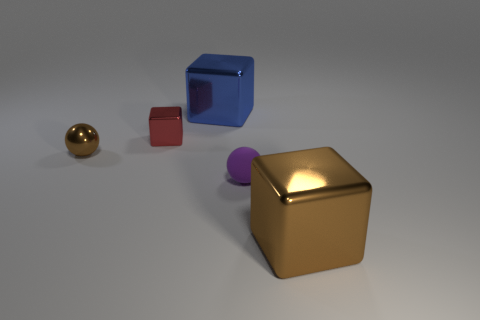There is a object that is the same size as the brown cube; what is its shape?
Keep it short and to the point. Cube. What is the color of the small thing that is on the left side of the small purple rubber sphere and on the right side of the small brown object?
Offer a terse response. Red. Is the size of the red metal thing the same as the shiny ball?
Offer a very short reply. Yes. What is the shape of the brown shiny thing left of the big metal block that is left of the big cube to the right of the big blue shiny block?
Keep it short and to the point. Sphere. Are there more tiny red things than small blue things?
Your answer should be compact. Yes. Are any brown cubes visible?
Provide a succinct answer. Yes. What number of things are either small things behind the tiny rubber thing or big objects that are to the right of the big blue shiny object?
Offer a very short reply. 3. Are there fewer matte objects than brown objects?
Offer a very short reply. Yes. Are there any tiny brown metal things left of the big brown metal cube?
Offer a very short reply. Yes. Is the material of the purple ball the same as the big brown block?
Give a very brief answer. No. 